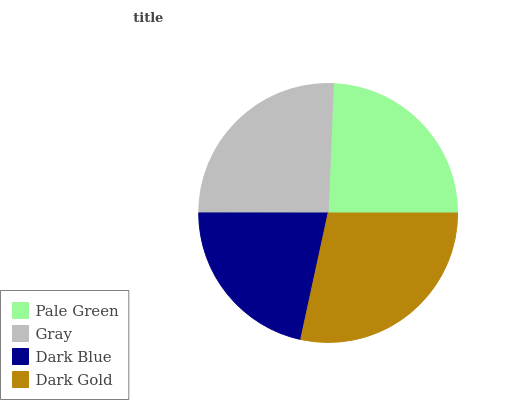Is Dark Blue the minimum?
Answer yes or no. Yes. Is Dark Gold the maximum?
Answer yes or no. Yes. Is Gray the minimum?
Answer yes or no. No. Is Gray the maximum?
Answer yes or no. No. Is Gray greater than Pale Green?
Answer yes or no. Yes. Is Pale Green less than Gray?
Answer yes or no. Yes. Is Pale Green greater than Gray?
Answer yes or no. No. Is Gray less than Pale Green?
Answer yes or no. No. Is Gray the high median?
Answer yes or no. Yes. Is Pale Green the low median?
Answer yes or no. Yes. Is Dark Gold the high median?
Answer yes or no. No. Is Dark Blue the low median?
Answer yes or no. No. 